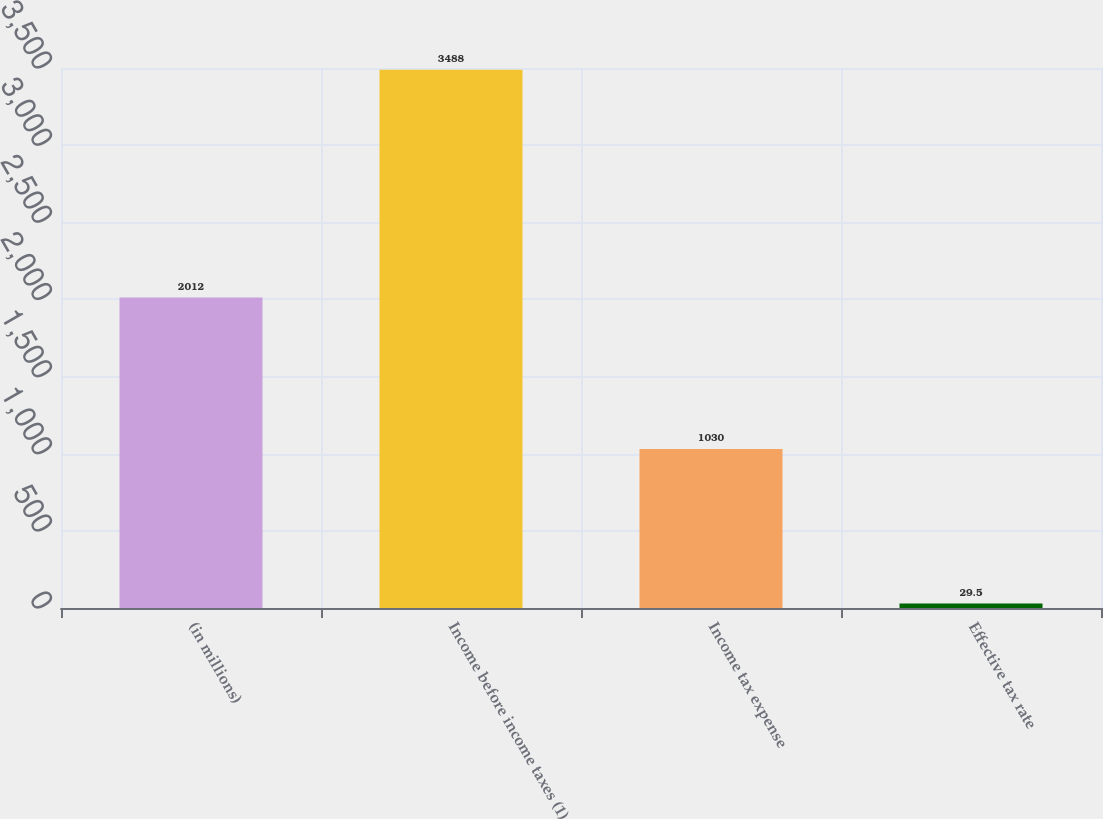Convert chart to OTSL. <chart><loc_0><loc_0><loc_500><loc_500><bar_chart><fcel>(in millions)<fcel>Income before income taxes (1)<fcel>Income tax expense<fcel>Effective tax rate<nl><fcel>2012<fcel>3488<fcel>1030<fcel>29.5<nl></chart> 